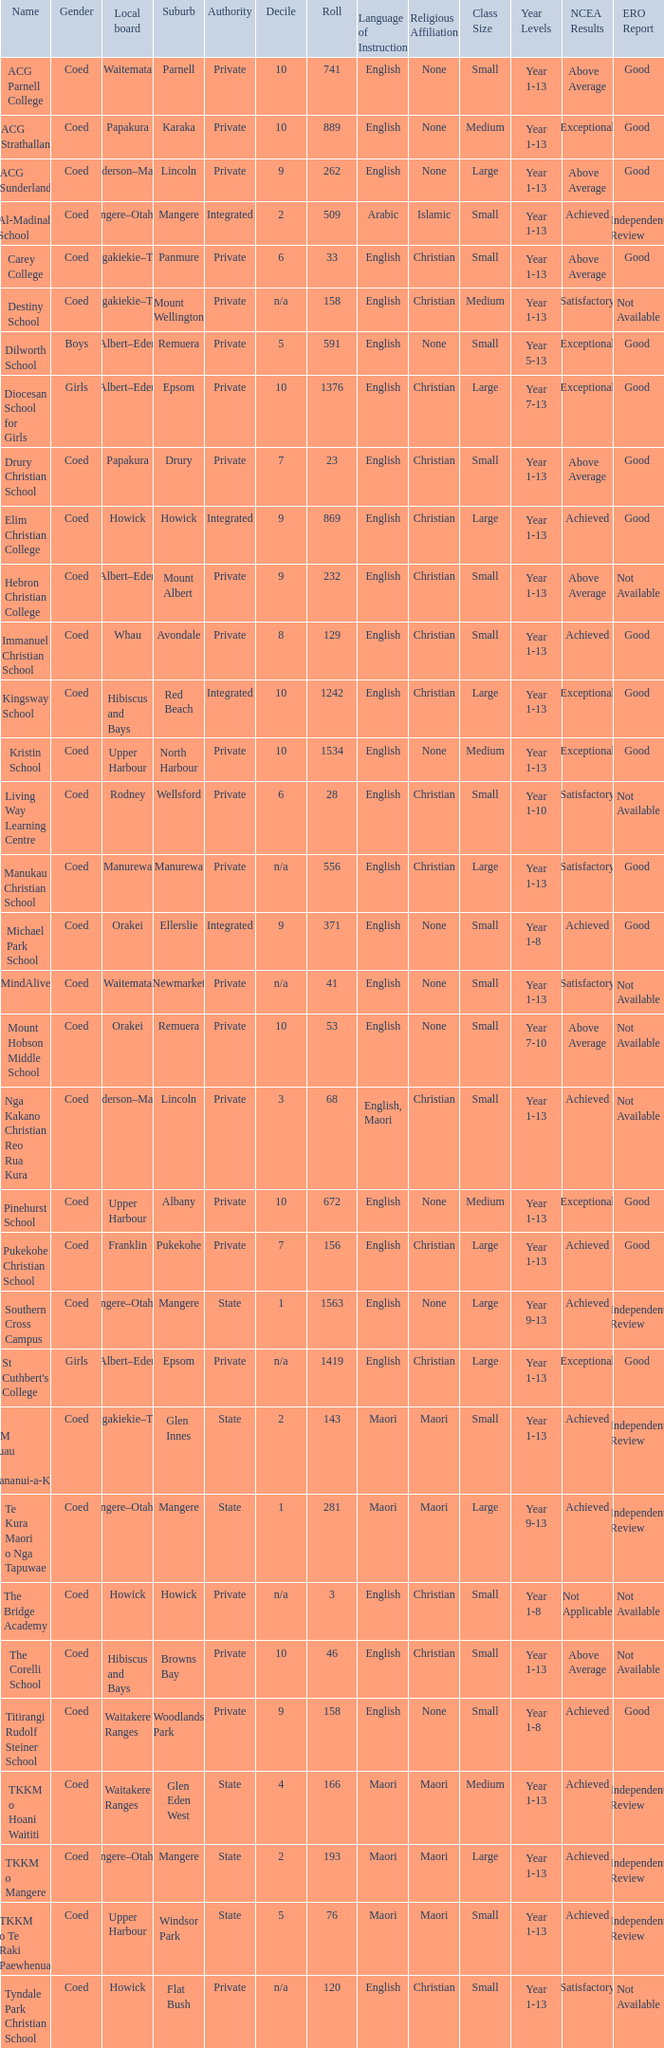What is the name of the suburb with a roll of 741? Parnell. 